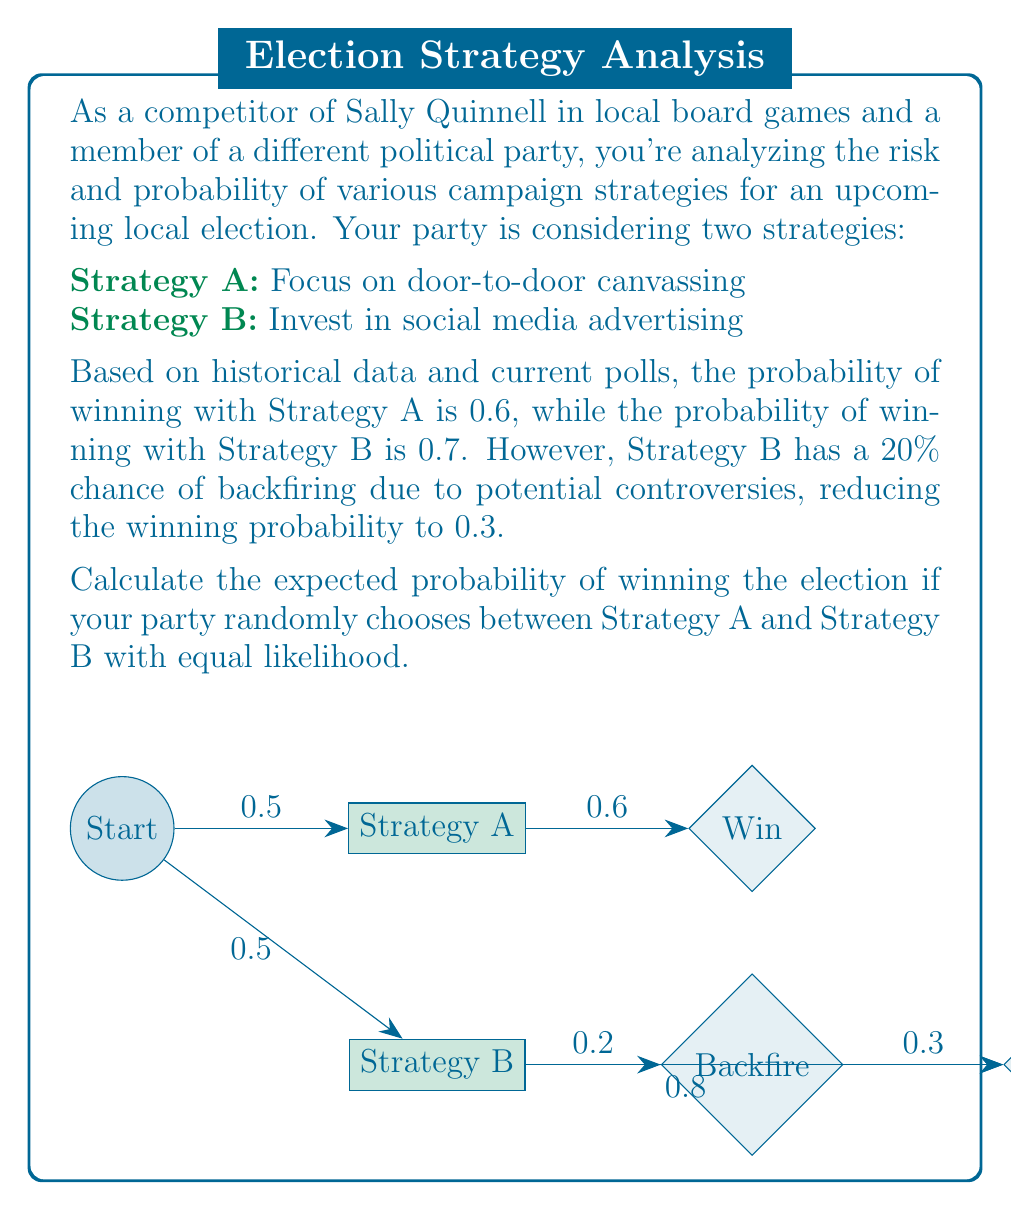Teach me how to tackle this problem. Let's approach this problem step-by-step:

1) First, we need to calculate the total probability of winning with Strategy B, considering both the successful and backfire scenarios:

   P(Win with B) = P(B succeeds) × P(Win | B succeeds) + P(B backfires) × P(Win | B backfires)
   $$ P(Win with B) = 0.8 \times 0.7 + 0.2 \times 0.3 = 0.56 + 0.06 = 0.62 $$

2) Now, we have the probability of winning for each strategy:
   Strategy A: 0.6
   Strategy B: 0.62

3) Since the party chooses between the strategies with equal likelihood (0.5 each), we can calculate the expected probability of winning as follows:

   $$ E(Win) = P(Choose A) \times P(Win with A) + P(Choose B) \times P(Win with B) $$
   $$ E(Win) = 0.5 \times 0.6 + 0.5 \times 0.62 $$
   $$ E(Win) = 0.3 + 0.31 = 0.61 $$

Therefore, the expected probability of winning the election is 0.61 or 61%.
Answer: 0.61 